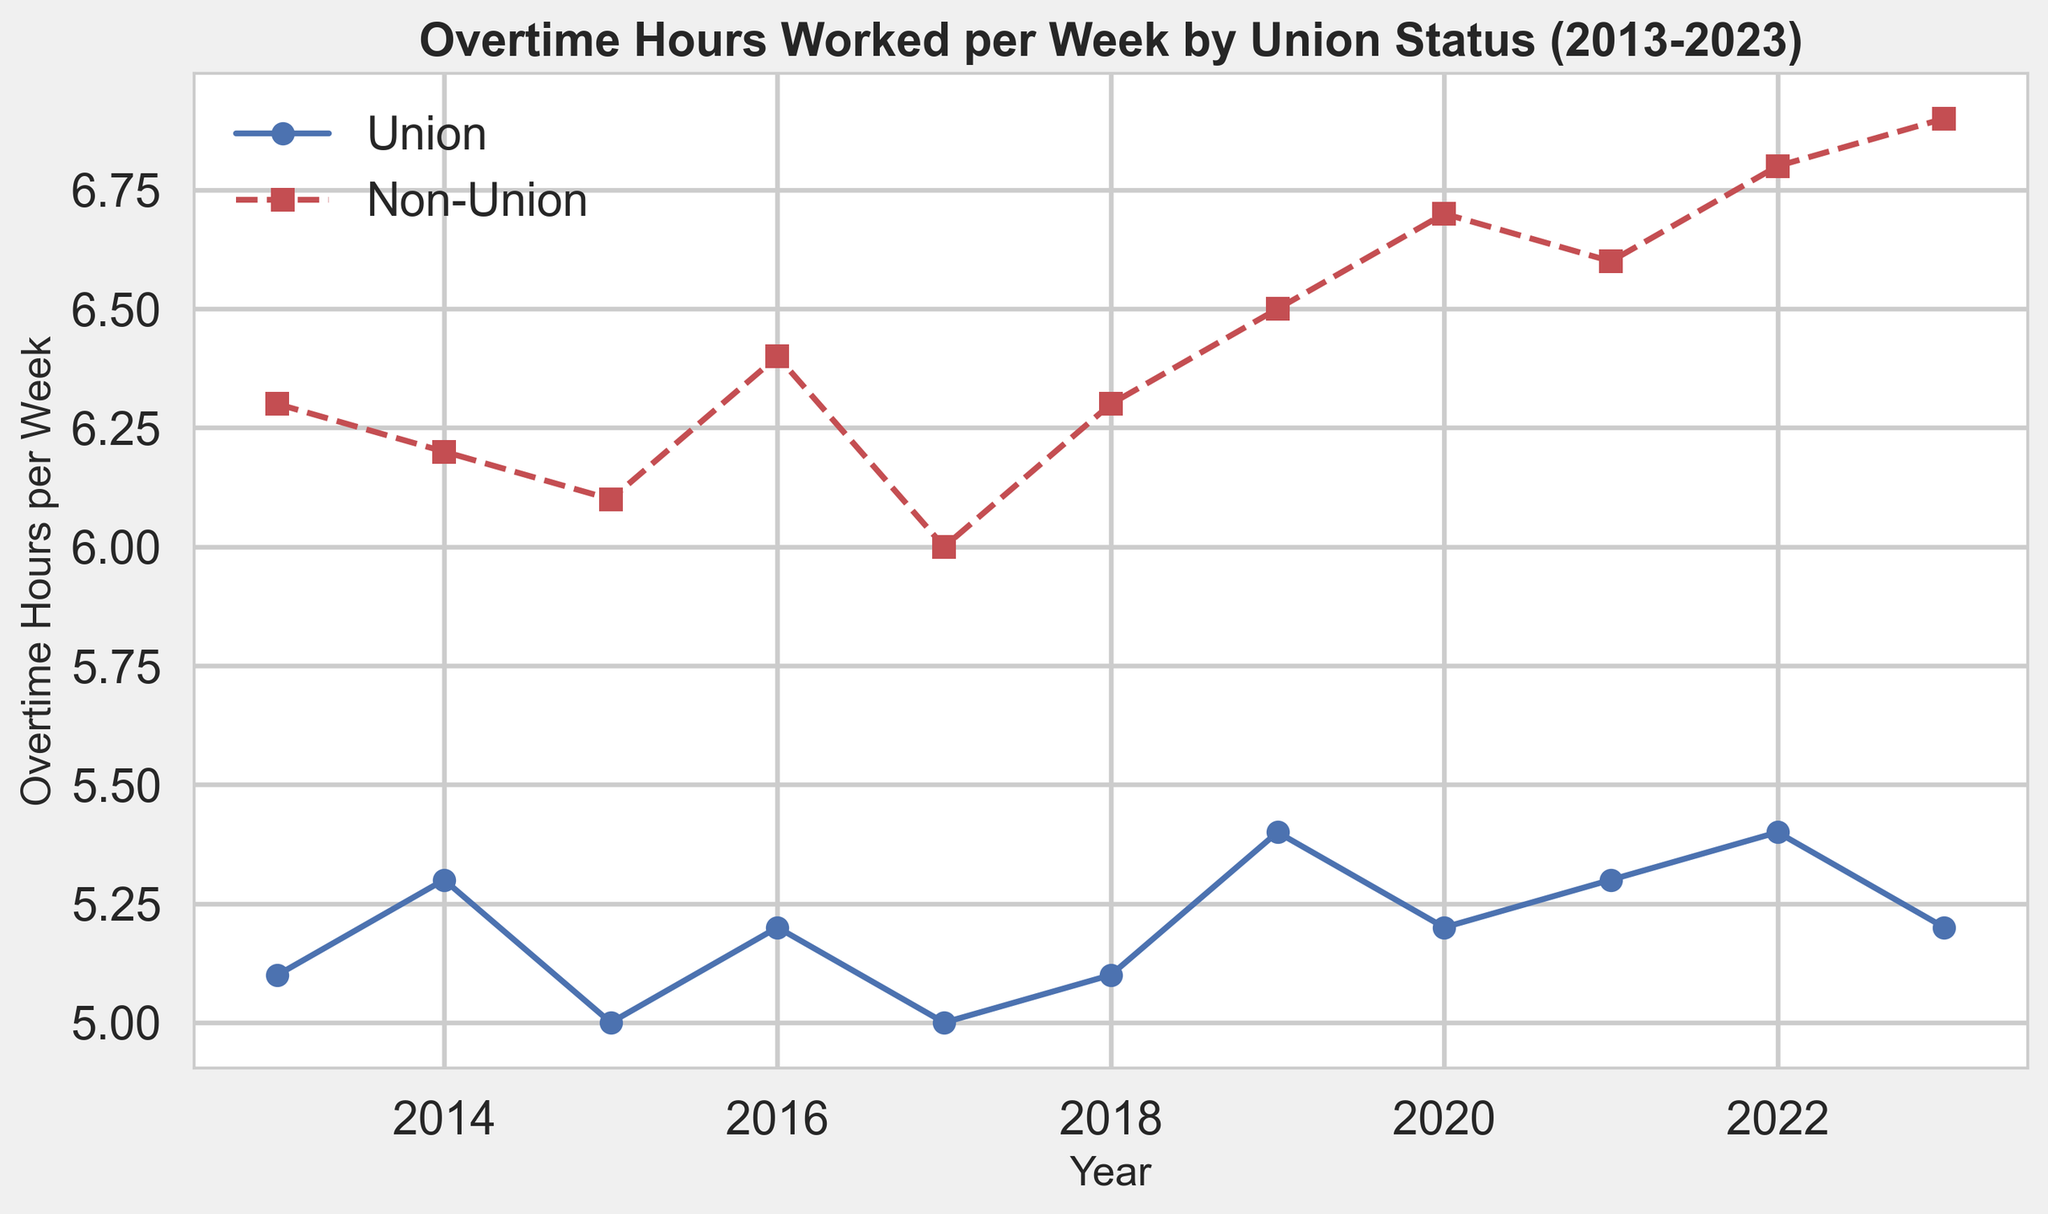Which year recorded the highest average overtime hours worked per week for non-union workers? From the figure, observe the line representing non-union workers (red line with square markers). The data point for the year 2023 is the highest on this line, indicating the year with the highest average overtime hours for non-union workers.
Answer: 2023 How did the overtime hours for union workers change from 2013 to 2023? Look at the starting and ending points of the blue line representing union workers. In 2013, the overtime hours were 5.1 hours per week. In 2023, they were 5.2 hours per week. The change is a slight increase of 0.1 hours over the decade.
Answer: Increased by 0.1 hours In which year did both union and non-union workers have the same overtime hours trend (both increased or both decreased)? Compare the trends for both lines year by year. Both lines show an increasing trend from 2018 to 2019 and a decreasing trend from 2015 to 2016.
Answer: 2015 to 2016 By how much did the overtime hours for non-union workers increase from 2013 to 2023? In 2013, the overtime hours for non-union workers were 6.3 hours per week, and in 2023, they were 6.9 hours per week. The increase is 6.9 - 6.3 = 0.6 hours.
Answer: Increased by 0.6 hours What was the average overtime worked per week by union workers from 2013 to 2023? Sum the overtime hours of union workers for all years and divide by the number of years. (5.1+5.3+5.0+5.2+5.0+5.1+5.4+5.2+5.3+5.4+5.2)/11 = 5.18 hours.
Answer: 5.18 hours Which group consistently worked more overtime hours per week? Observe which line (blue for union or red for non-union) is always higher across all years. The red line representing non-union workers is consistently above the blue line for union workers.
Answer: Non-union workers In which year did the smallest difference in overtime hours between union and non-union workers occur? Calculate the differences for each year and find the smallest one:  
2013: 6.3 - 5.1 = 1.2  
2014: 6.2 - 5.3 = 0.9  
2015: 6.1 - 5.0 = 1.1  
2016: 6.4 - 5.2 = 1.2  
2017: 6.0 - 5.0 = 1.0  
2018: 6.3 - 5.1 = 1.2  
2019: 6.5 - 5.4 = 1.1  
2020: 6.7-5.2 = 1.5  
2021: 6.6 - 5.3 = 1.3  
2022: 6.8 - 5.4 = 1.4  
2023: 6.9 - 5.2 = 1.7  
The year 2014 shows the smallest difference of 0.9 hours.
Answer: 2014 